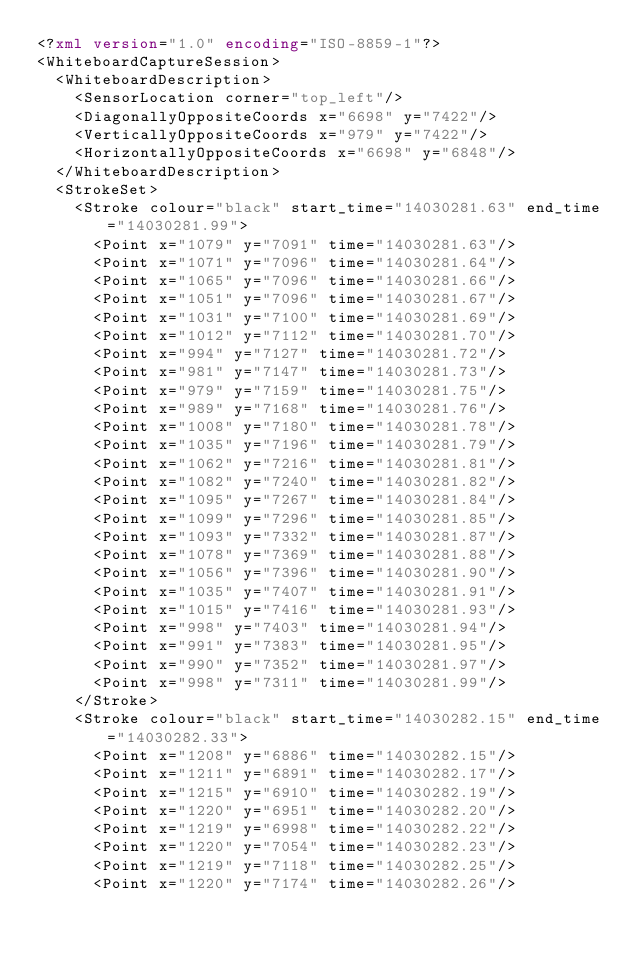Convert code to text. <code><loc_0><loc_0><loc_500><loc_500><_XML_><?xml version="1.0" encoding="ISO-8859-1"?>
<WhiteboardCaptureSession>
  <WhiteboardDescription>
    <SensorLocation corner="top_left"/>
    <DiagonallyOppositeCoords x="6698" y="7422"/>
    <VerticallyOppositeCoords x="979" y="7422"/>
    <HorizontallyOppositeCoords x="6698" y="6848"/>
  </WhiteboardDescription>
  <StrokeSet>
    <Stroke colour="black" start_time="14030281.63" end_time="14030281.99">
      <Point x="1079" y="7091" time="14030281.63"/>
      <Point x="1071" y="7096" time="14030281.64"/>
      <Point x="1065" y="7096" time="14030281.66"/>
      <Point x="1051" y="7096" time="14030281.67"/>
      <Point x="1031" y="7100" time="14030281.69"/>
      <Point x="1012" y="7112" time="14030281.70"/>
      <Point x="994" y="7127" time="14030281.72"/>
      <Point x="981" y="7147" time="14030281.73"/>
      <Point x="979" y="7159" time="14030281.75"/>
      <Point x="989" y="7168" time="14030281.76"/>
      <Point x="1008" y="7180" time="14030281.78"/>
      <Point x="1035" y="7196" time="14030281.79"/>
      <Point x="1062" y="7216" time="14030281.81"/>
      <Point x="1082" y="7240" time="14030281.82"/>
      <Point x="1095" y="7267" time="14030281.84"/>
      <Point x="1099" y="7296" time="14030281.85"/>
      <Point x="1093" y="7332" time="14030281.87"/>
      <Point x="1078" y="7369" time="14030281.88"/>
      <Point x="1056" y="7396" time="14030281.90"/>
      <Point x="1035" y="7407" time="14030281.91"/>
      <Point x="1015" y="7416" time="14030281.93"/>
      <Point x="998" y="7403" time="14030281.94"/>
      <Point x="991" y="7383" time="14030281.95"/>
      <Point x="990" y="7352" time="14030281.97"/>
      <Point x="998" y="7311" time="14030281.99"/>
    </Stroke>
    <Stroke colour="black" start_time="14030282.15" end_time="14030282.33">
      <Point x="1208" y="6886" time="14030282.15"/>
      <Point x="1211" y="6891" time="14030282.17"/>
      <Point x="1215" y="6910" time="14030282.19"/>
      <Point x="1220" y="6951" time="14030282.20"/>
      <Point x="1219" y="6998" time="14030282.22"/>
      <Point x="1220" y="7054" time="14030282.23"/>
      <Point x="1219" y="7118" time="14030282.25"/>
      <Point x="1220" y="7174" time="14030282.26"/></code> 